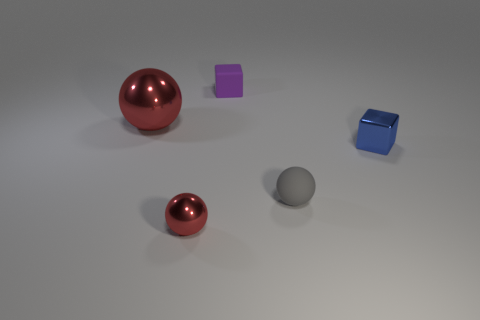Subtract all gray cylinders. How many red balls are left? 2 Subtract all metallic spheres. How many spheres are left? 1 Add 5 small purple matte things. How many objects exist? 10 Subtract all cubes. How many objects are left? 3 Add 3 red things. How many red things exist? 5 Subtract 1 blue cubes. How many objects are left? 4 Subtract all green cubes. Subtract all tiny blue metal objects. How many objects are left? 4 Add 1 blue shiny cubes. How many blue shiny cubes are left? 2 